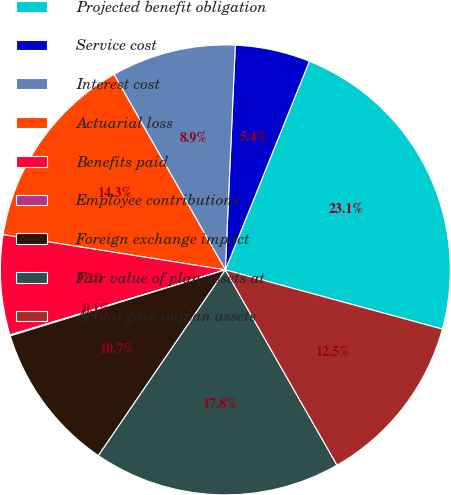Convert chart. <chart><loc_0><loc_0><loc_500><loc_500><pie_chart><fcel>Projected benefit obligation<fcel>Service cost<fcel>Interest cost<fcel>Actuarial loss<fcel>Benefits paid<fcel>Employee contributions<fcel>Foreign exchange impact<fcel>Fair value of plan assets at<fcel>Actual gain onplan assets<nl><fcel>23.14%<fcel>5.39%<fcel>8.94%<fcel>14.26%<fcel>7.17%<fcel>0.07%<fcel>10.72%<fcel>17.81%<fcel>12.49%<nl></chart> 